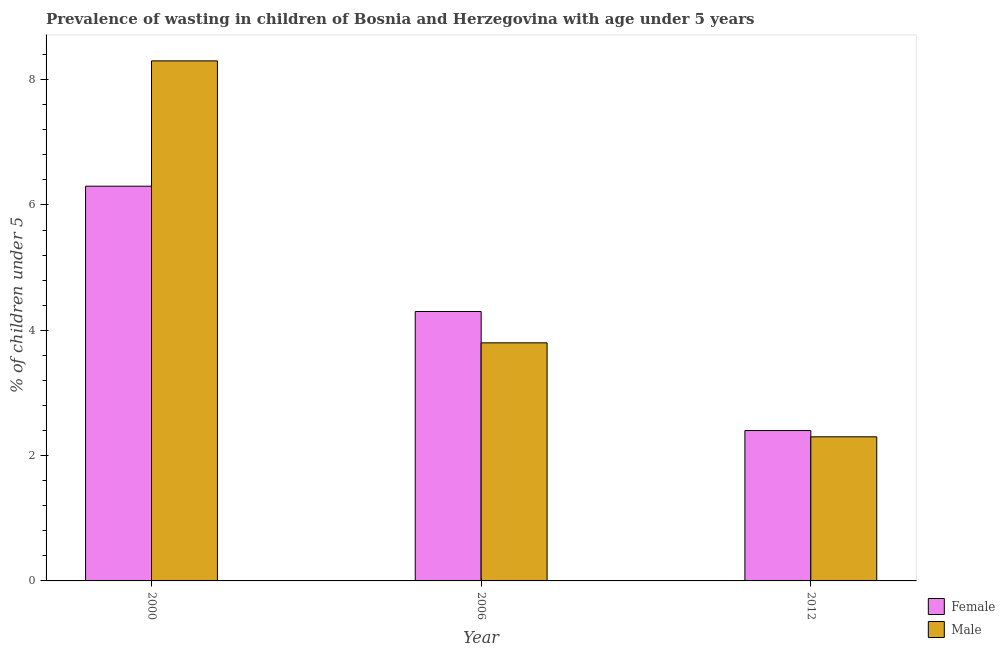How many groups of bars are there?
Ensure brevity in your answer.  3. Are the number of bars per tick equal to the number of legend labels?
Your answer should be very brief. Yes. How many bars are there on the 2nd tick from the left?
Make the answer very short. 2. How many bars are there on the 1st tick from the right?
Give a very brief answer. 2. What is the label of the 3rd group of bars from the left?
Keep it short and to the point. 2012. What is the percentage of undernourished male children in 2012?
Make the answer very short. 2.3. Across all years, what is the maximum percentage of undernourished female children?
Give a very brief answer. 6.3. Across all years, what is the minimum percentage of undernourished male children?
Give a very brief answer. 2.3. What is the total percentage of undernourished male children in the graph?
Offer a terse response. 14.4. What is the difference between the percentage of undernourished female children in 2000 and that in 2006?
Your response must be concise. 2. What is the difference between the percentage of undernourished female children in 2006 and the percentage of undernourished male children in 2000?
Offer a very short reply. -2. What is the average percentage of undernourished male children per year?
Offer a terse response. 4.8. In the year 2006, what is the difference between the percentage of undernourished male children and percentage of undernourished female children?
Provide a succinct answer. 0. In how many years, is the percentage of undernourished female children greater than 3.6 %?
Offer a very short reply. 2. What is the ratio of the percentage of undernourished female children in 2000 to that in 2012?
Keep it short and to the point. 2.62. Is the percentage of undernourished female children in 2000 less than that in 2012?
Your response must be concise. No. Is the difference between the percentage of undernourished male children in 2006 and 2012 greater than the difference between the percentage of undernourished female children in 2006 and 2012?
Make the answer very short. No. What is the difference between the highest and the second highest percentage of undernourished female children?
Offer a very short reply. 2. What is the difference between the highest and the lowest percentage of undernourished female children?
Your response must be concise. 3.9. In how many years, is the percentage of undernourished male children greater than the average percentage of undernourished male children taken over all years?
Your answer should be compact. 1. Is the sum of the percentage of undernourished male children in 2006 and 2012 greater than the maximum percentage of undernourished female children across all years?
Make the answer very short. No. What does the 2nd bar from the left in 2006 represents?
Make the answer very short. Male. Are all the bars in the graph horizontal?
Give a very brief answer. No. How many years are there in the graph?
Your response must be concise. 3. What is the difference between two consecutive major ticks on the Y-axis?
Your answer should be very brief. 2. Does the graph contain any zero values?
Keep it short and to the point. No. Does the graph contain grids?
Your response must be concise. No. Where does the legend appear in the graph?
Offer a terse response. Bottom right. How many legend labels are there?
Give a very brief answer. 2. What is the title of the graph?
Your answer should be very brief. Prevalence of wasting in children of Bosnia and Herzegovina with age under 5 years. Does "current US$" appear as one of the legend labels in the graph?
Your answer should be very brief. No. What is the label or title of the X-axis?
Keep it short and to the point. Year. What is the label or title of the Y-axis?
Provide a succinct answer.  % of children under 5. What is the  % of children under 5 in Female in 2000?
Your answer should be very brief. 6.3. What is the  % of children under 5 of Male in 2000?
Your answer should be very brief. 8.3. What is the  % of children under 5 of Female in 2006?
Ensure brevity in your answer.  4.3. What is the  % of children under 5 in Male in 2006?
Your answer should be very brief. 3.8. What is the  % of children under 5 of Female in 2012?
Ensure brevity in your answer.  2.4. What is the  % of children under 5 of Male in 2012?
Ensure brevity in your answer.  2.3. Across all years, what is the maximum  % of children under 5 in Female?
Your answer should be compact. 6.3. Across all years, what is the maximum  % of children under 5 in Male?
Your response must be concise. 8.3. Across all years, what is the minimum  % of children under 5 in Female?
Your response must be concise. 2.4. Across all years, what is the minimum  % of children under 5 of Male?
Your answer should be compact. 2.3. What is the total  % of children under 5 of Female in the graph?
Offer a very short reply. 13. What is the total  % of children under 5 of Male in the graph?
Make the answer very short. 14.4. What is the difference between the  % of children under 5 in Female in 2000 and that in 2006?
Ensure brevity in your answer.  2. What is the difference between the  % of children under 5 in Male in 2000 and that in 2006?
Provide a succinct answer. 4.5. What is the difference between the  % of children under 5 in Male in 2000 and that in 2012?
Your answer should be very brief. 6. What is the difference between the  % of children under 5 of Female in 2006 and that in 2012?
Provide a short and direct response. 1.9. What is the difference between the  % of children under 5 in Male in 2006 and that in 2012?
Give a very brief answer. 1.5. What is the difference between the  % of children under 5 of Female in 2006 and the  % of children under 5 of Male in 2012?
Offer a terse response. 2. What is the average  % of children under 5 of Female per year?
Your answer should be compact. 4.33. What is the average  % of children under 5 in Male per year?
Offer a terse response. 4.8. In the year 2006, what is the difference between the  % of children under 5 of Female and  % of children under 5 of Male?
Ensure brevity in your answer.  0.5. What is the ratio of the  % of children under 5 in Female in 2000 to that in 2006?
Your response must be concise. 1.47. What is the ratio of the  % of children under 5 in Male in 2000 to that in 2006?
Your response must be concise. 2.18. What is the ratio of the  % of children under 5 of Female in 2000 to that in 2012?
Your answer should be compact. 2.62. What is the ratio of the  % of children under 5 of Male in 2000 to that in 2012?
Offer a terse response. 3.61. What is the ratio of the  % of children under 5 in Female in 2006 to that in 2012?
Provide a succinct answer. 1.79. What is the ratio of the  % of children under 5 of Male in 2006 to that in 2012?
Your answer should be compact. 1.65. What is the difference between the highest and the second highest  % of children under 5 of Male?
Keep it short and to the point. 4.5. What is the difference between the highest and the lowest  % of children under 5 of Male?
Your response must be concise. 6. 